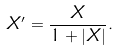Convert formula to latex. <formula><loc_0><loc_0><loc_500><loc_500>X ^ { \prime } = \frac { X } { 1 + | X | } .</formula> 